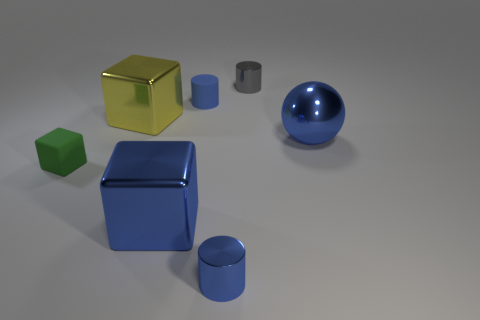What material is the small thing that is in front of the tiny gray shiny cylinder and behind the green thing?
Make the answer very short. Rubber. What size is the matte thing that is the same color as the large metal ball?
Your answer should be compact. Small. Does the yellow object to the right of the tiny cube have the same shape as the matte thing behind the tiny green thing?
Provide a short and direct response. No. Are any tiny green shiny blocks visible?
Offer a terse response. No. What color is the other big object that is the same shape as the yellow metal object?
Your answer should be very brief. Blue. What is the color of the block that is the same size as the gray thing?
Offer a very short reply. Green. Do the small green cube and the blue cube have the same material?
Ensure brevity in your answer.  No. What number of small shiny things have the same color as the big metal sphere?
Provide a short and direct response. 1. Does the large shiny ball have the same color as the rubber block?
Offer a very short reply. No. There is a blue thing on the right side of the gray cylinder; what material is it?
Offer a very short reply. Metal. 